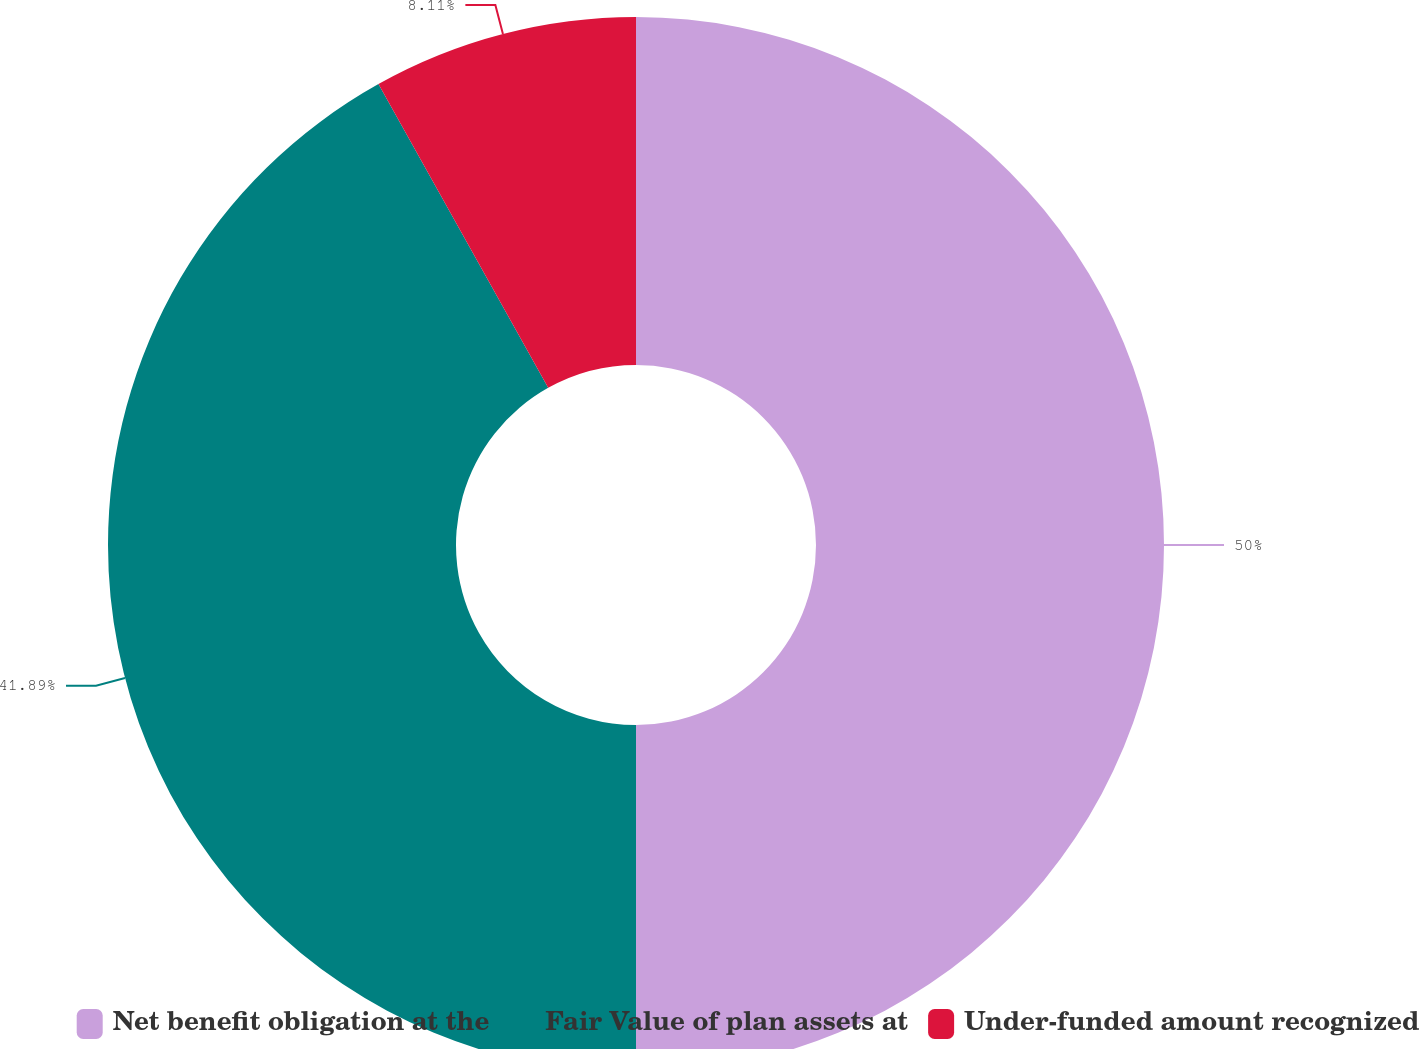<chart> <loc_0><loc_0><loc_500><loc_500><pie_chart><fcel>Net benefit obligation at the<fcel>Fair Value of plan assets at<fcel>Under-funded amount recognized<nl><fcel>50.0%<fcel>41.89%<fcel>8.11%<nl></chart> 